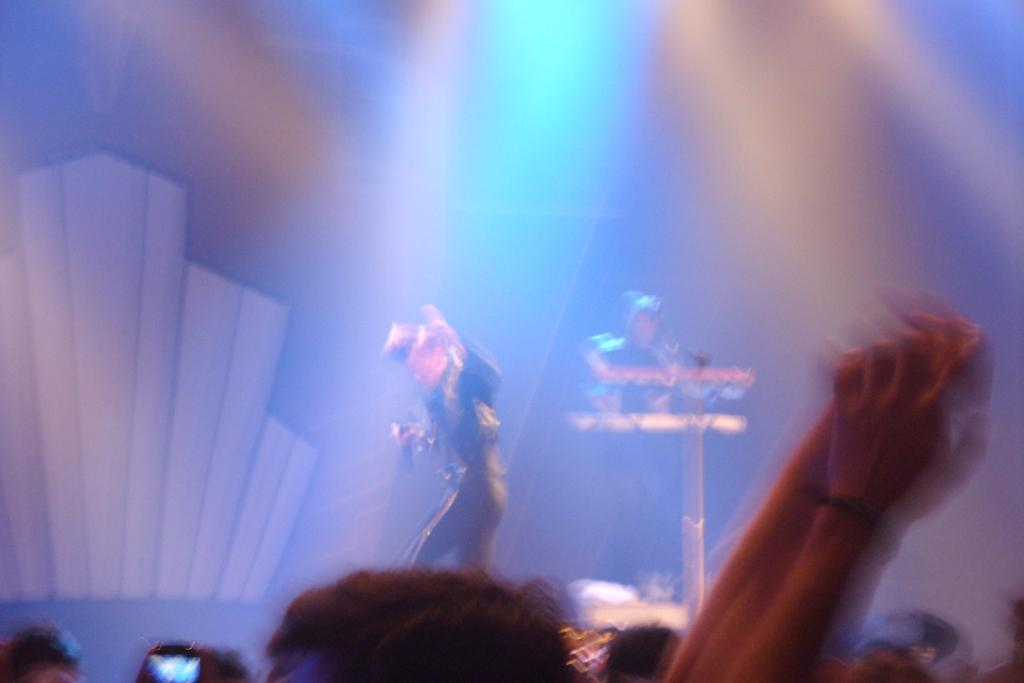What is the person in the image wearing? The person is wearing a black dress in the image. What is the person with the black dress doing? The person is standing and holding a mic in his hand. Can you describe the person behind the person with the mic? There is another person behind the person with the mic, but no specific details about their appearance are provided. Who is present in front of the two people? There are audience members in front of the two people. What type of hydrant is visible in the image? There is no hydrant present in the image. What color is the powder being used by the person with the mic? There is no mention of powder being used by the person with the mic in the image. 